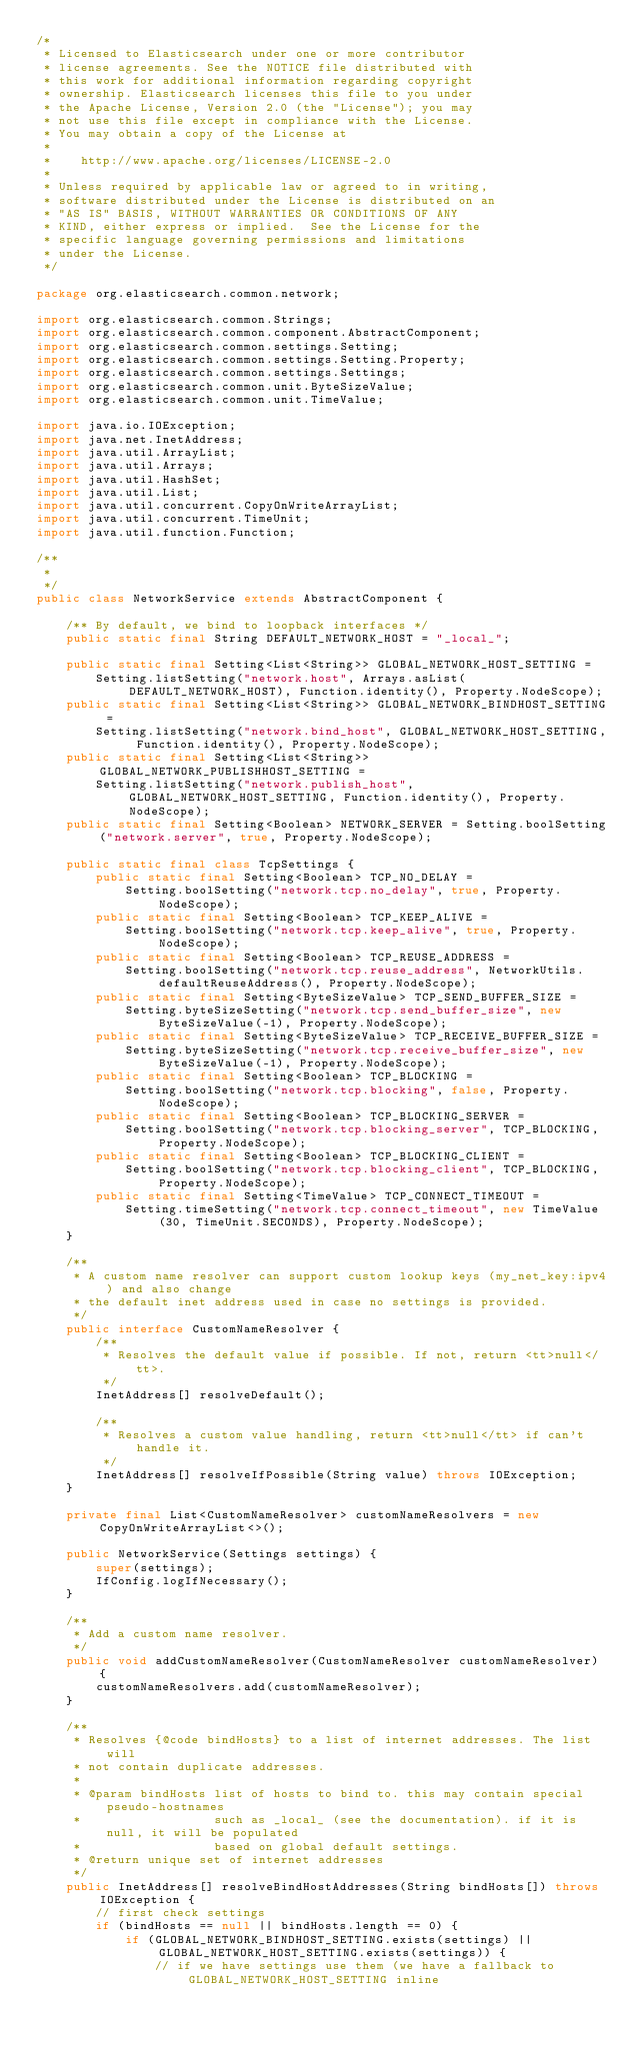Convert code to text. <code><loc_0><loc_0><loc_500><loc_500><_Java_>/*
 * Licensed to Elasticsearch under one or more contributor
 * license agreements. See the NOTICE file distributed with
 * this work for additional information regarding copyright
 * ownership. Elasticsearch licenses this file to you under
 * the Apache License, Version 2.0 (the "License"); you may
 * not use this file except in compliance with the License.
 * You may obtain a copy of the License at
 *
 *    http://www.apache.org/licenses/LICENSE-2.0
 *
 * Unless required by applicable law or agreed to in writing,
 * software distributed under the License is distributed on an
 * "AS IS" BASIS, WITHOUT WARRANTIES OR CONDITIONS OF ANY
 * KIND, either express or implied.  See the License for the
 * specific language governing permissions and limitations
 * under the License.
 */

package org.elasticsearch.common.network;

import org.elasticsearch.common.Strings;
import org.elasticsearch.common.component.AbstractComponent;
import org.elasticsearch.common.settings.Setting;
import org.elasticsearch.common.settings.Setting.Property;
import org.elasticsearch.common.settings.Settings;
import org.elasticsearch.common.unit.ByteSizeValue;
import org.elasticsearch.common.unit.TimeValue;

import java.io.IOException;
import java.net.InetAddress;
import java.util.ArrayList;
import java.util.Arrays;
import java.util.HashSet;
import java.util.List;
import java.util.concurrent.CopyOnWriteArrayList;
import java.util.concurrent.TimeUnit;
import java.util.function.Function;

/**
 *
 */
public class NetworkService extends AbstractComponent {

    /** By default, we bind to loopback interfaces */
    public static final String DEFAULT_NETWORK_HOST = "_local_";

    public static final Setting<List<String>> GLOBAL_NETWORK_HOST_SETTING =
        Setting.listSetting("network.host", Arrays.asList(DEFAULT_NETWORK_HOST), Function.identity(), Property.NodeScope);
    public static final Setting<List<String>> GLOBAL_NETWORK_BINDHOST_SETTING =
        Setting.listSetting("network.bind_host", GLOBAL_NETWORK_HOST_SETTING, Function.identity(), Property.NodeScope);
    public static final Setting<List<String>> GLOBAL_NETWORK_PUBLISHHOST_SETTING =
        Setting.listSetting("network.publish_host", GLOBAL_NETWORK_HOST_SETTING, Function.identity(), Property.NodeScope);
    public static final Setting<Boolean> NETWORK_SERVER = Setting.boolSetting("network.server", true, Property.NodeScope);

    public static final class TcpSettings {
        public static final Setting<Boolean> TCP_NO_DELAY =
            Setting.boolSetting("network.tcp.no_delay", true, Property.NodeScope);
        public static final Setting<Boolean> TCP_KEEP_ALIVE =
            Setting.boolSetting("network.tcp.keep_alive", true, Property.NodeScope);
        public static final Setting<Boolean> TCP_REUSE_ADDRESS =
            Setting.boolSetting("network.tcp.reuse_address", NetworkUtils.defaultReuseAddress(), Property.NodeScope);
        public static final Setting<ByteSizeValue> TCP_SEND_BUFFER_SIZE =
            Setting.byteSizeSetting("network.tcp.send_buffer_size", new ByteSizeValue(-1), Property.NodeScope);
        public static final Setting<ByteSizeValue> TCP_RECEIVE_BUFFER_SIZE =
            Setting.byteSizeSetting("network.tcp.receive_buffer_size", new ByteSizeValue(-1), Property.NodeScope);
        public static final Setting<Boolean> TCP_BLOCKING =
            Setting.boolSetting("network.tcp.blocking", false, Property.NodeScope);
        public static final Setting<Boolean> TCP_BLOCKING_SERVER =
            Setting.boolSetting("network.tcp.blocking_server", TCP_BLOCKING, Property.NodeScope);
        public static final Setting<Boolean> TCP_BLOCKING_CLIENT =
            Setting.boolSetting("network.tcp.blocking_client", TCP_BLOCKING, Property.NodeScope);
        public static final Setting<TimeValue> TCP_CONNECT_TIMEOUT =
            Setting.timeSetting("network.tcp.connect_timeout", new TimeValue(30, TimeUnit.SECONDS), Property.NodeScope);
    }

    /**
     * A custom name resolver can support custom lookup keys (my_net_key:ipv4) and also change
     * the default inet address used in case no settings is provided.
     */
    public interface CustomNameResolver {
        /**
         * Resolves the default value if possible. If not, return <tt>null</tt>.
         */
        InetAddress[] resolveDefault();

        /**
         * Resolves a custom value handling, return <tt>null</tt> if can't handle it.
         */
        InetAddress[] resolveIfPossible(String value) throws IOException;
    }

    private final List<CustomNameResolver> customNameResolvers = new CopyOnWriteArrayList<>();

    public NetworkService(Settings settings) {
        super(settings);
        IfConfig.logIfNecessary();
    }

    /**
     * Add a custom name resolver.
     */
    public void addCustomNameResolver(CustomNameResolver customNameResolver) {
        customNameResolvers.add(customNameResolver);
    }

    /**
     * Resolves {@code bindHosts} to a list of internet addresses. The list will
     * not contain duplicate addresses.
     *
     * @param bindHosts list of hosts to bind to. this may contain special pseudo-hostnames
     *                  such as _local_ (see the documentation). if it is null, it will be populated
     *                  based on global default settings.
     * @return unique set of internet addresses
     */
    public InetAddress[] resolveBindHostAddresses(String bindHosts[]) throws IOException {
        // first check settings
        if (bindHosts == null || bindHosts.length == 0) {
            if (GLOBAL_NETWORK_BINDHOST_SETTING.exists(settings) || GLOBAL_NETWORK_HOST_SETTING.exists(settings)) {
                // if we have settings use them (we have a fallback to GLOBAL_NETWORK_HOST_SETTING inline</code> 